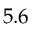Convert formula to latex. <formula><loc_0><loc_0><loc_500><loc_500>5 . 6</formula> 